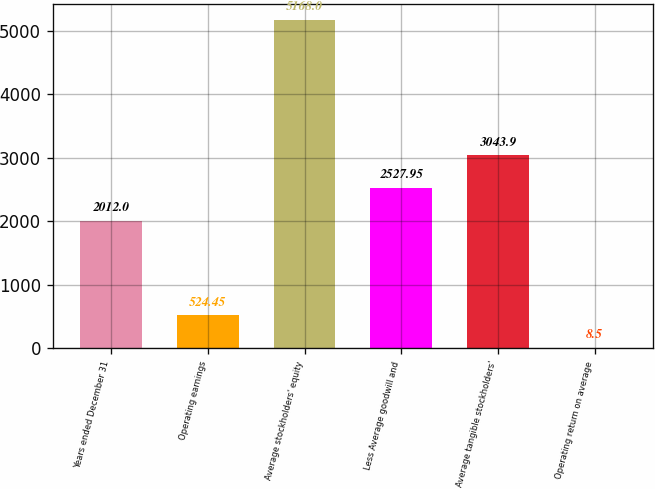Convert chart to OTSL. <chart><loc_0><loc_0><loc_500><loc_500><bar_chart><fcel>Years ended December 31<fcel>Operating earnings<fcel>Average stockholders' equity<fcel>Less Average goodwill and<fcel>Average tangible stockholders'<fcel>Operating return on average<nl><fcel>2012<fcel>524.45<fcel>5168<fcel>2527.95<fcel>3043.9<fcel>8.5<nl></chart> 